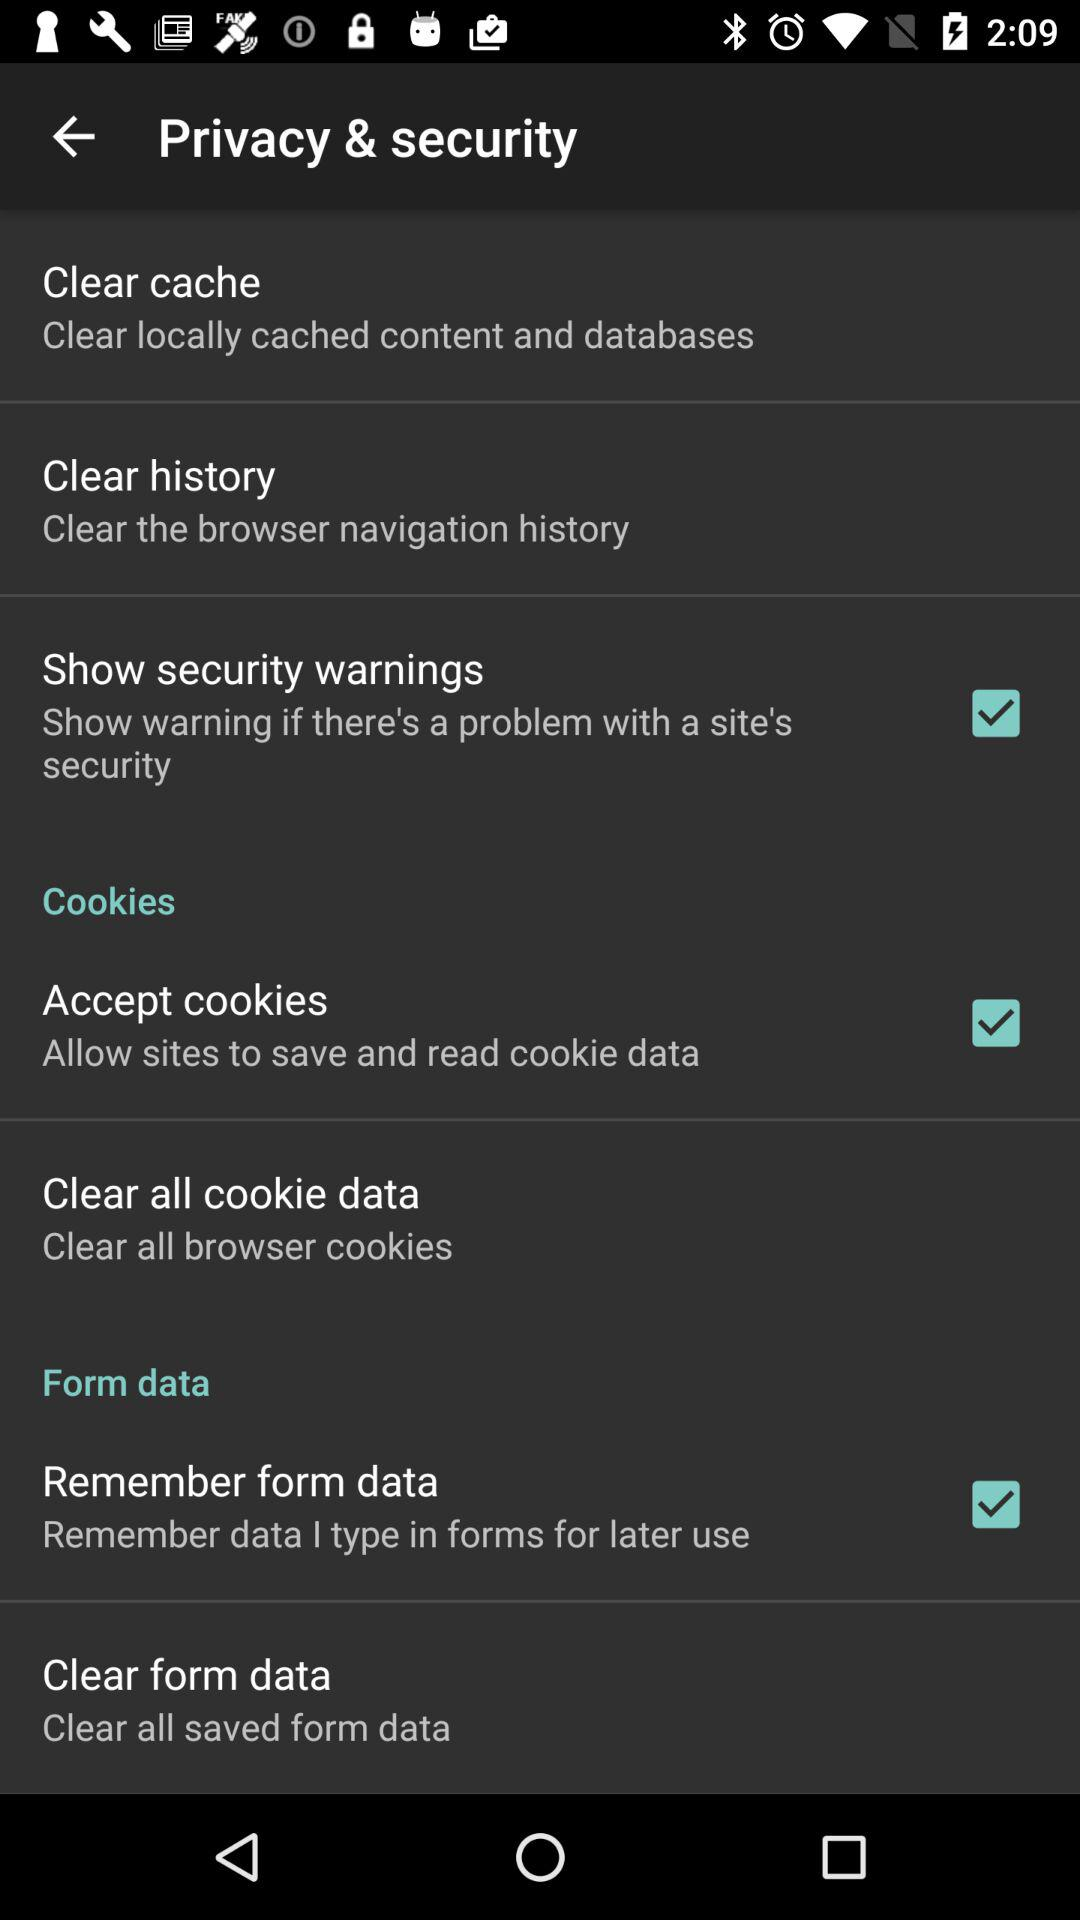Which privacy and security options are checked? The checked privacy and security options are "Show security warnings", "Accept cookies" and "Remember from data". 